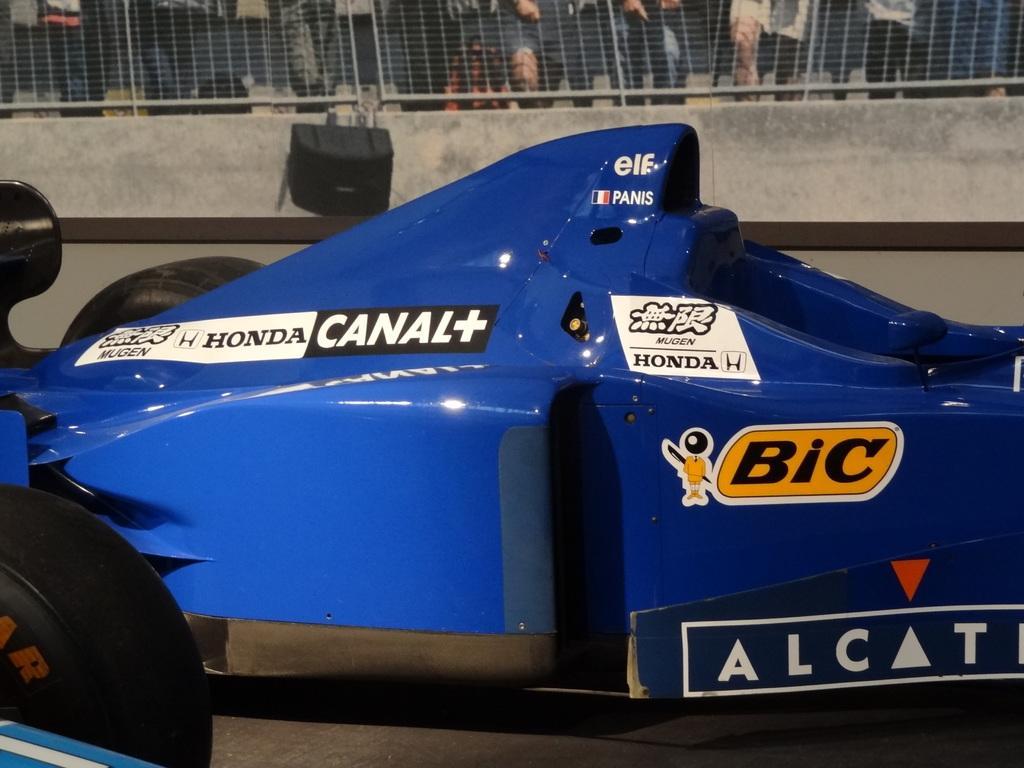In one or two sentences, can you explain what this image depicts? Here we can see a vehicle on a platform. In the background there is an object on a wall and few persons are standing at the fence. 